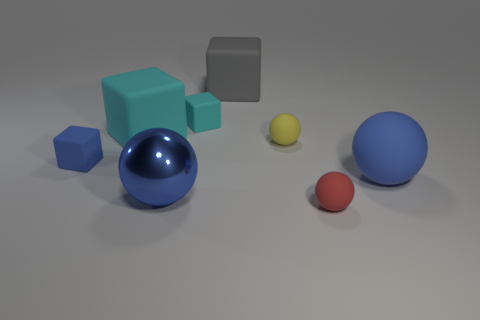Subtract all shiny balls. How many balls are left? 3 Add 1 big objects. How many objects exist? 9 Subtract all blue balls. How many balls are left? 2 Subtract 3 cubes. How many cubes are left? 1 Subtract all blue spheres. Subtract all green cylinders. How many spheres are left? 2 Add 3 blue objects. How many blue objects exist? 6 Subtract 1 cyan blocks. How many objects are left? 7 Subtract all green cylinders. How many cyan balls are left? 0 Subtract all balls. Subtract all tiny green metallic blocks. How many objects are left? 4 Add 4 tiny yellow objects. How many tiny yellow objects are left? 5 